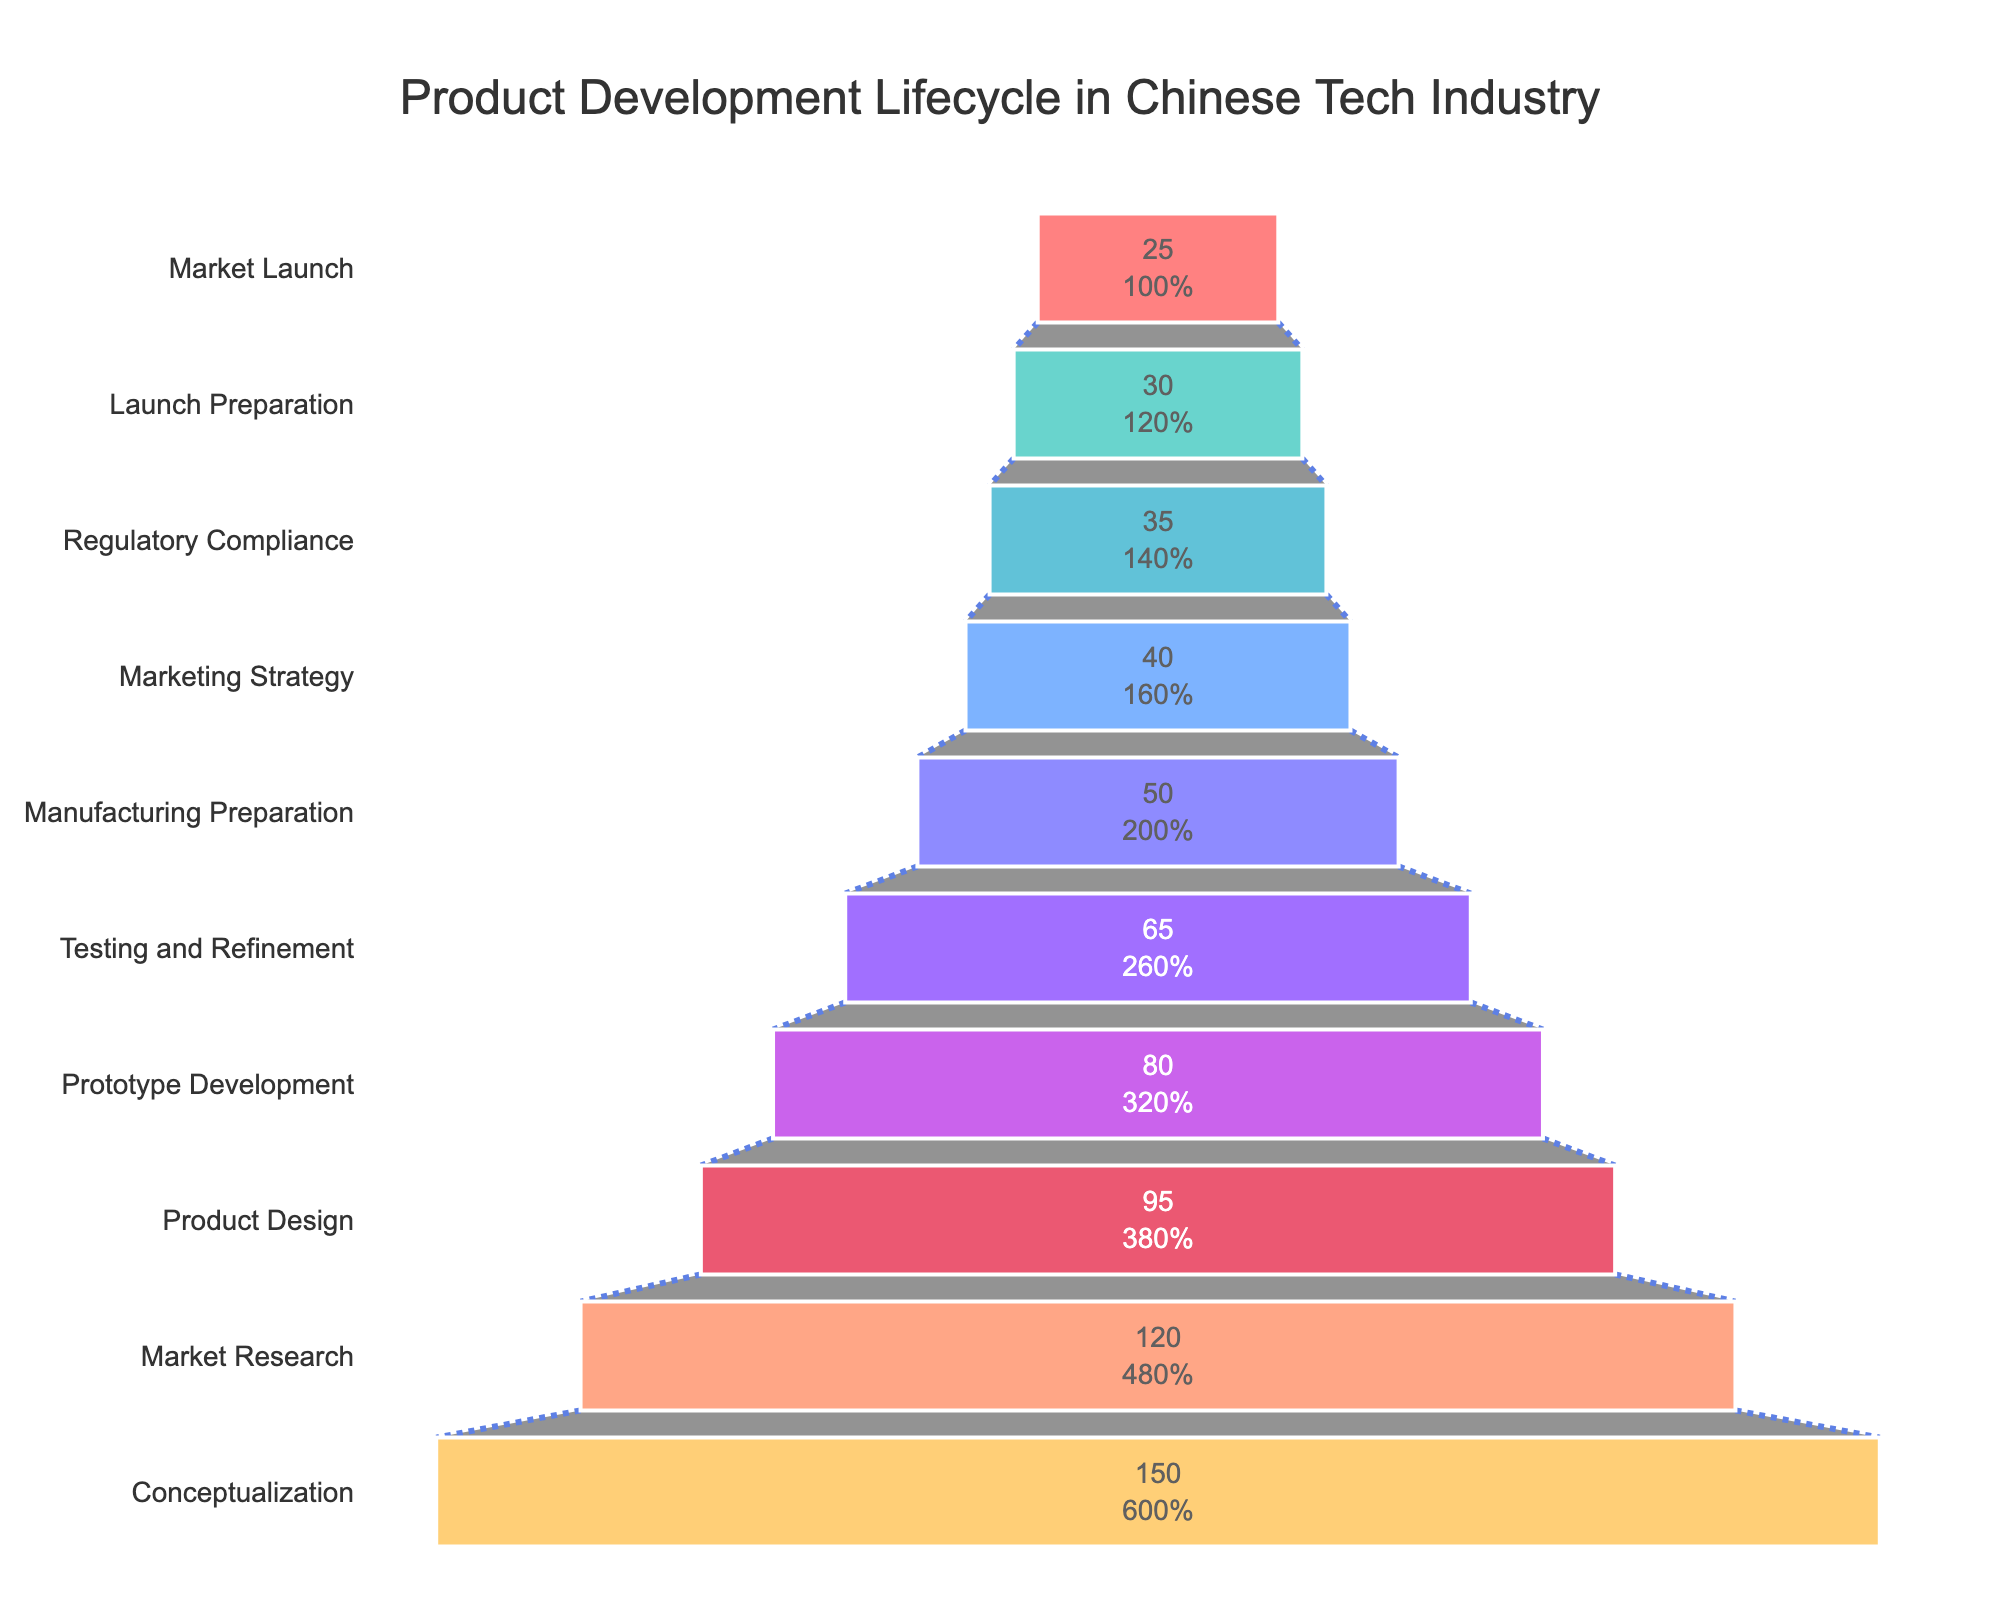Which stage has the highest number of projects? The stage with the highest number of projects is observed from the widest section at the top of the funnel chart.
Answer: Conceptualization How many projects drop off between the Market Research and Product Design stages? To find the number of projects that drop off, subtract the number of projects in the Product Design stage from those in the Market Research stage (120 - 95).
Answer: 25 What is the average number of projects from Prototype Development to Launch Preparation? Add the number of projects in each stage from Prototype Development to Launch Preparation and divide by the number of stages (80 + 65 + 50 + 40 + 35 + 30)/6.
Answer: 50 Which stage has the lowest number of projects? The lowest number of projects can be identified by the narrowest section at the bottom of the funnel chart.
Answer: Market Launch Is the number of projects remaining at the Market Launch stage more or less than half of the number at the Conceptualization stage? Compare the number of projects at the Market Launch stage (25) with half the number at the Conceptualization stage (150/2 = 75). 25 is less than 75.
Answer: Less Compare the number of projects at the Manufacturing Preparation and Testing and Refinement stages. Which stage has more projects? The number of projects in the Manufacturing Preparation stage (50) is compared to those in the Testing and Refinement stage (65). 65 is greater than 50.
Answer: Testing and Refinement What is the percentage drop in projects from Manufacturing Preparation to Market Launch? Calculate the percentage drop using the formula [(50 - 25) / 50] * 100 to get the percentage decrease.
Answer: 50% What fraction of the projects that reach Prototype Development make it to Market Launch? Divide the number of projects that make it to Market Launch (25) by those in Prototype Development (80) and simplify if possible.
Answer: 5/16 Which stage immediately follows Product Design in the lifecycle? By following the descending order of stages, the stage immediately after Product Design is discerned.
Answer: Prototype Development How many stages have fewer than 50 projects? Count the number of stages where the number of projects is less than 50. By observation, this includes Marketing Strategy, Regulatory Compliance, Launch Preparation, and Market Launch.
Answer: 4 